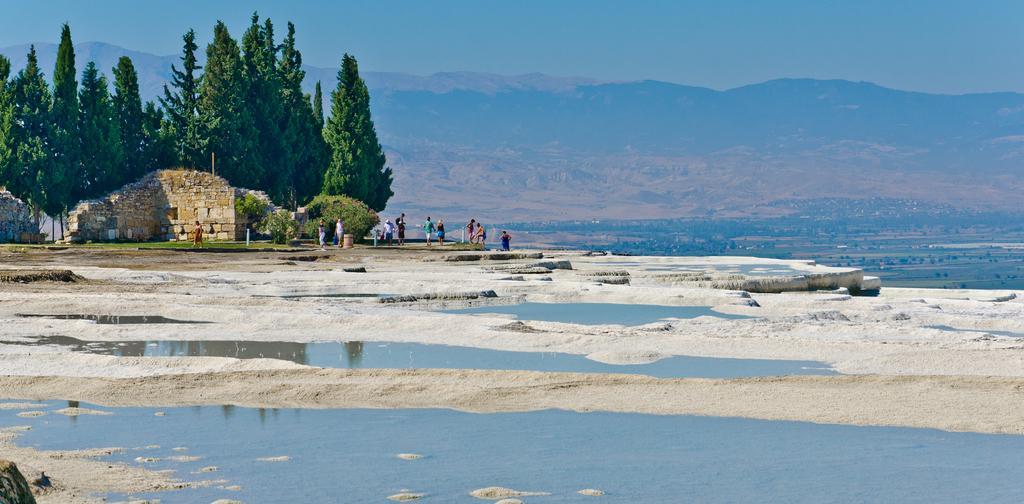In one or two sentences, can you explain what this image depicts? In this image I can see mountains, trees and some rock constructions, some people standing and walking besides the trees and rocks. I can see some water pools at the bottom of the image. At the top of the image I can see the sky.  